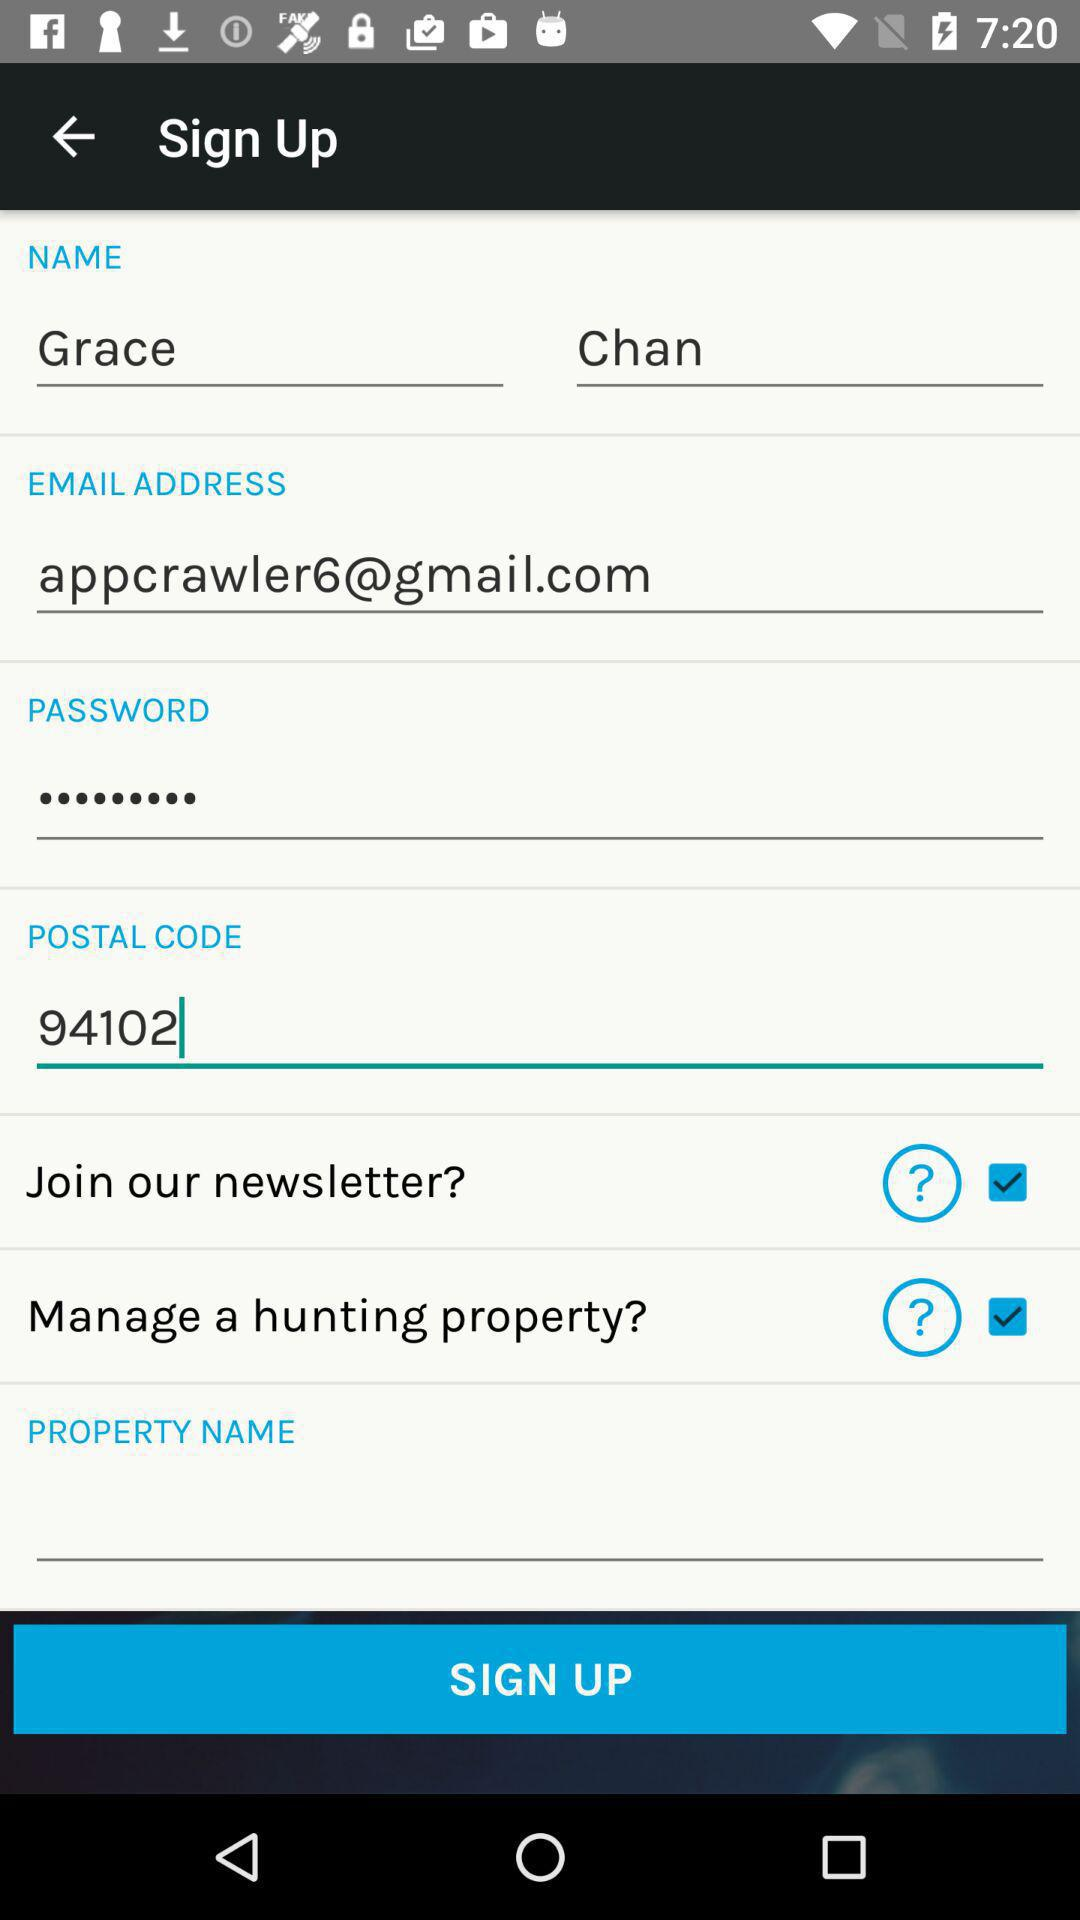What is the status of the "Manage a hunting property"? The status is "on". 